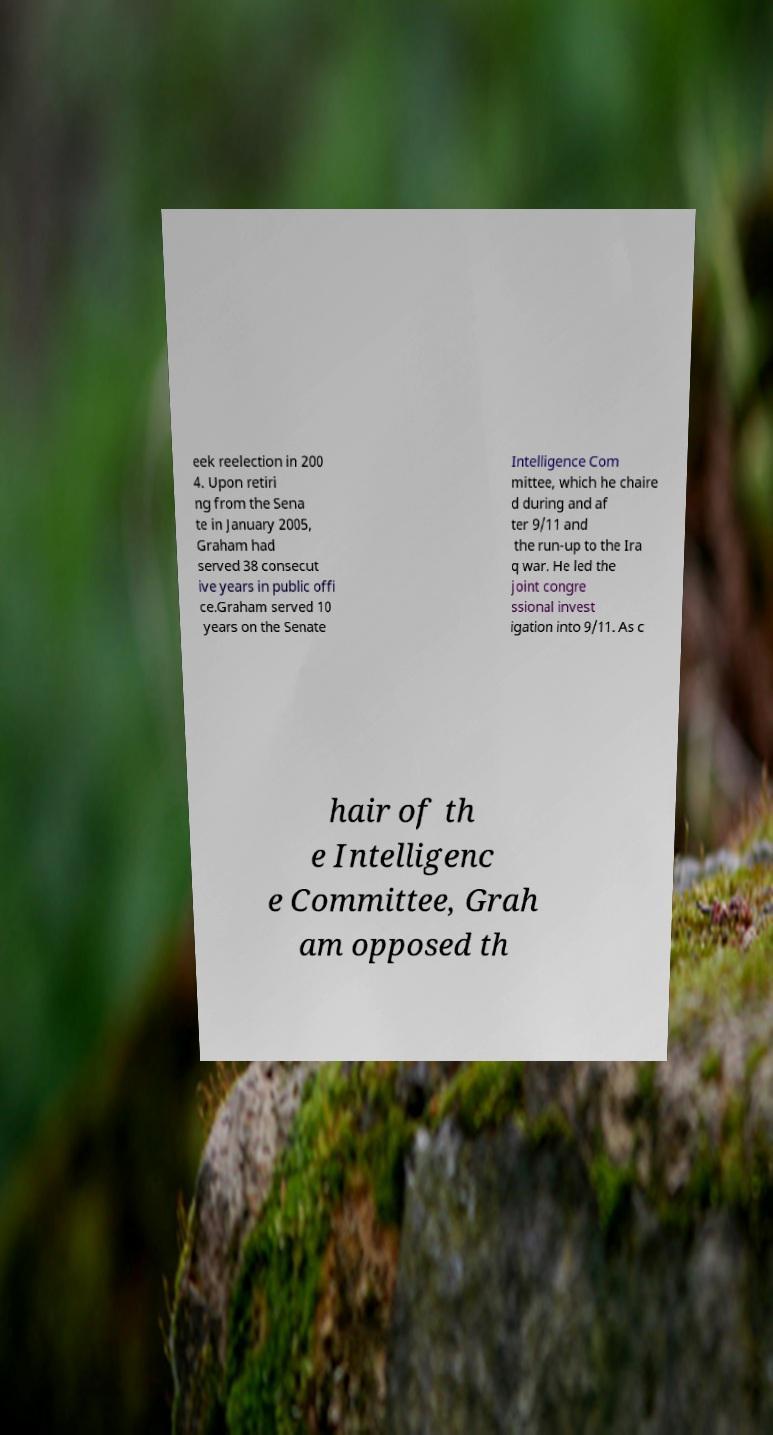I need the written content from this picture converted into text. Can you do that? eek reelection in 200 4. Upon retiri ng from the Sena te in January 2005, Graham had served 38 consecut ive years in public offi ce.Graham served 10 years on the Senate Intelligence Com mittee, which he chaire d during and af ter 9/11 and the run-up to the Ira q war. He led the joint congre ssional invest igation into 9/11. As c hair of th e Intelligenc e Committee, Grah am opposed th 